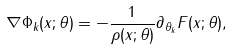Convert formula to latex. <formula><loc_0><loc_0><loc_500><loc_500>\nabla \Phi _ { k } ( x ; \theta ) = - \frac { 1 } { \rho ( x ; \theta ) } \partial _ { \theta _ { k } } F ( x ; \theta ) ,</formula> 